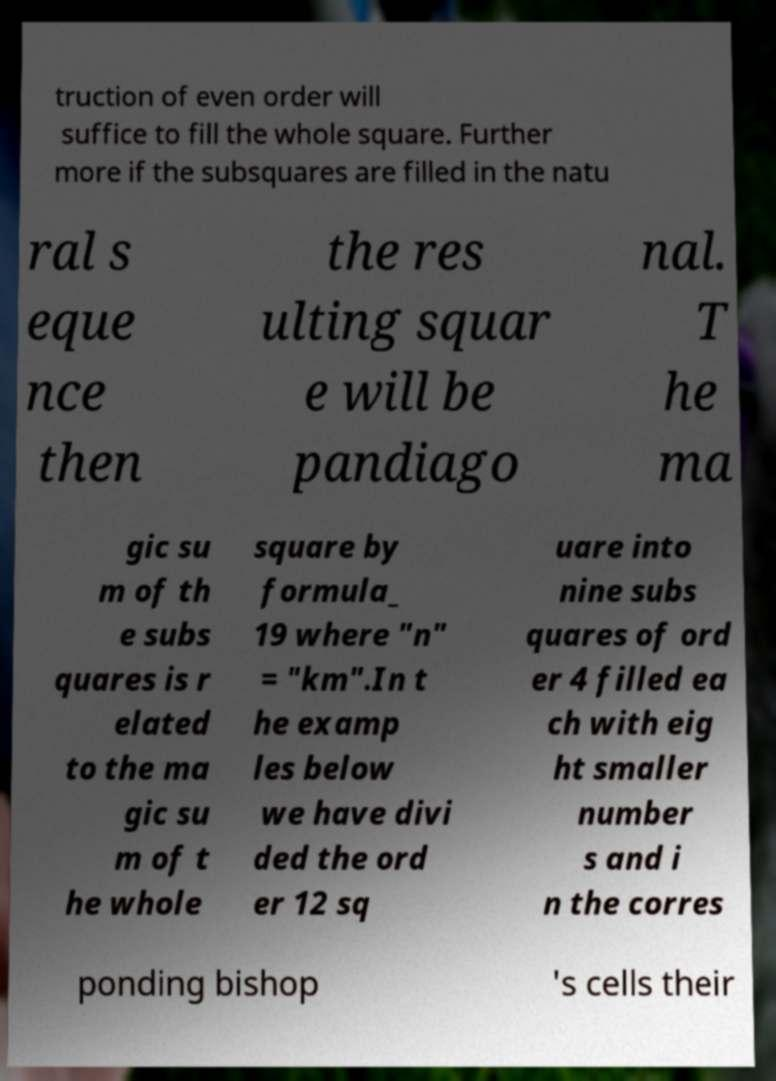What messages or text are displayed in this image? I need them in a readable, typed format. truction of even order will suffice to fill the whole square. Further more if the subsquares are filled in the natu ral s eque nce then the res ulting squar e will be pandiago nal. T he ma gic su m of th e subs quares is r elated to the ma gic su m of t he whole square by formula_ 19 where "n" = "km".In t he examp les below we have divi ded the ord er 12 sq uare into nine subs quares of ord er 4 filled ea ch with eig ht smaller number s and i n the corres ponding bishop 's cells their 